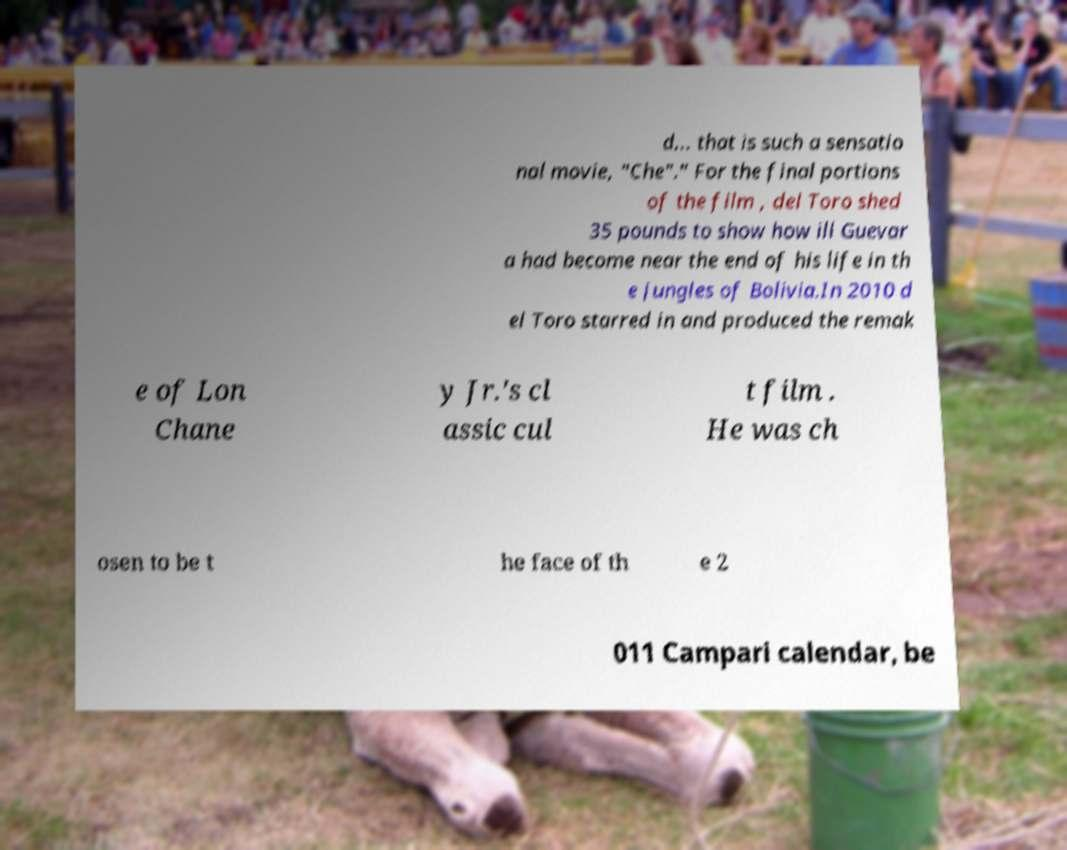Could you assist in decoding the text presented in this image and type it out clearly? d... that is such a sensatio nal movie, "Che"." For the final portions of the film , del Toro shed 35 pounds to show how ill Guevar a had become near the end of his life in th e jungles of Bolivia.In 2010 d el Toro starred in and produced the remak e of Lon Chane y Jr.'s cl assic cul t film . He was ch osen to be t he face of th e 2 011 Campari calendar, be 